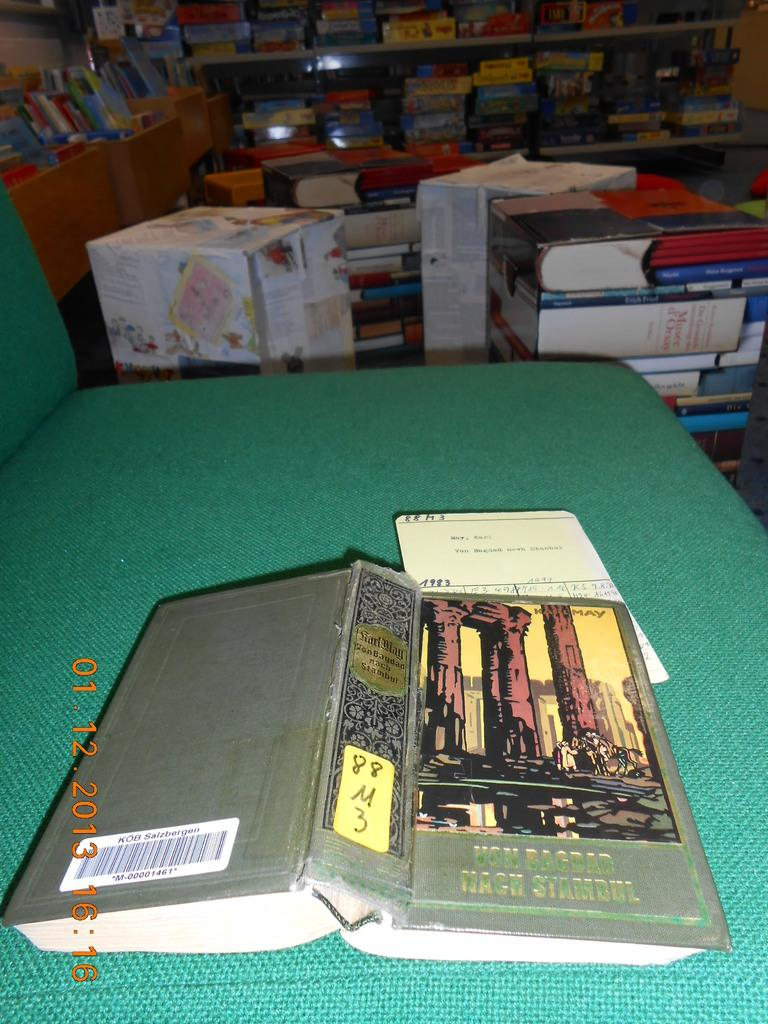<image>
Describe the image concisely. A book open in the middle laying face down on a table with the title VON BAGBAD WACH STAMBUL. 